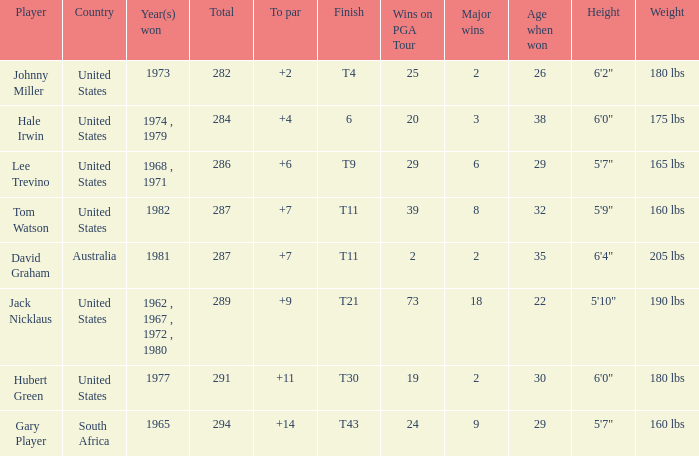WHAT IS THE TOTAL, OF A TO PAR FOR HUBERT GREEN, AND A TOTAL LARGER THAN 291? 0.0. 